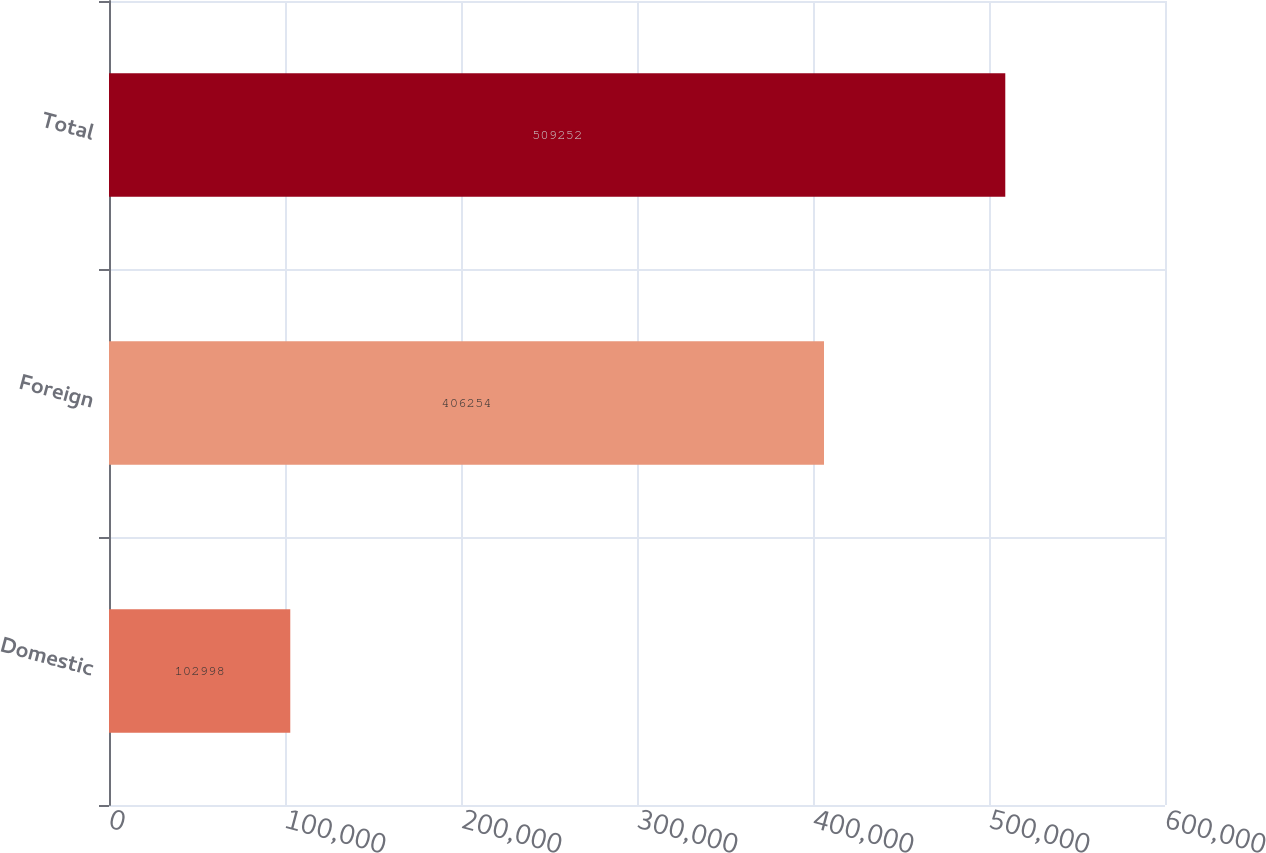Convert chart to OTSL. <chart><loc_0><loc_0><loc_500><loc_500><bar_chart><fcel>Domestic<fcel>Foreign<fcel>Total<nl><fcel>102998<fcel>406254<fcel>509252<nl></chart> 